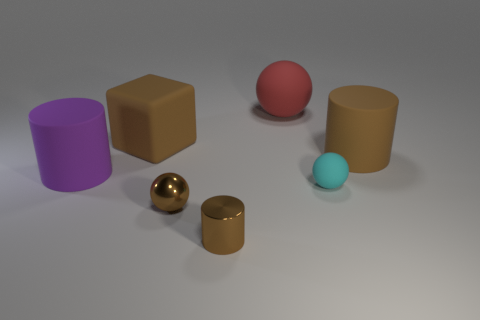There is a brown object that is both left of the big rubber sphere and behind the brown shiny sphere; what material is it?
Your answer should be compact. Rubber. Is the cylinder that is in front of the tiny cyan matte thing made of the same material as the purple thing?
Offer a very short reply. No. There is a big red ball to the left of the small cyan matte ball; what is it made of?
Ensure brevity in your answer.  Rubber. What is the size of the rubber ball behind the big matte block?
Offer a terse response. Large. What size is the purple cylinder?
Keep it short and to the point. Large. What is the size of the brown cylinder behind the big matte cylinder on the left side of the small shiny thing to the left of the small cylinder?
Keep it short and to the point. Large. Is there a large purple cylinder made of the same material as the big cube?
Your answer should be very brief. Yes. There is a purple thing; what shape is it?
Ensure brevity in your answer.  Cylinder. What color is the other large cylinder that is made of the same material as the large brown cylinder?
Your answer should be very brief. Purple. What number of gray objects are spheres or small rubber cylinders?
Make the answer very short. 0. 